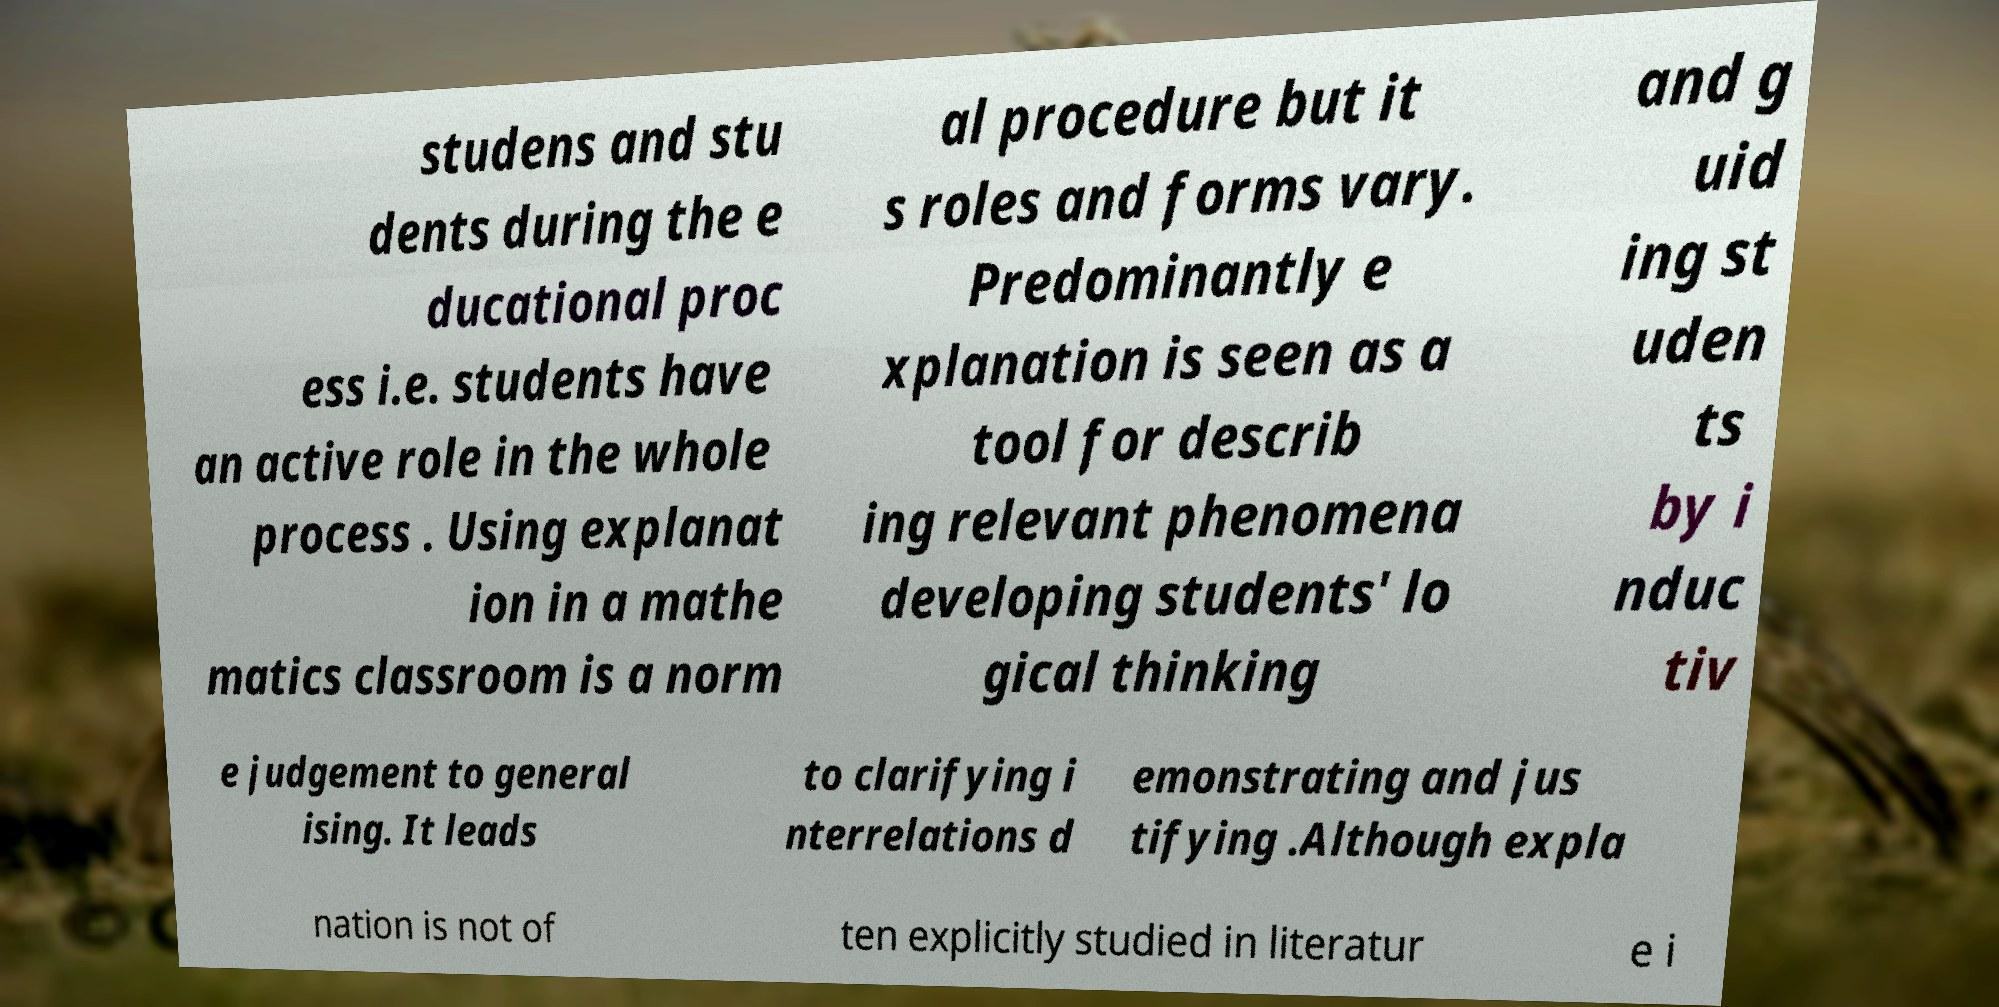I need the written content from this picture converted into text. Can you do that? studens and stu dents during the e ducational proc ess i.e. students have an active role in the whole process . Using explanat ion in a mathe matics classroom is a norm al procedure but it s roles and forms vary. Predominantly e xplanation is seen as a tool for describ ing relevant phenomena developing students' lo gical thinking and g uid ing st uden ts by i nduc tiv e judgement to general ising. It leads to clarifying i nterrelations d emonstrating and jus tifying .Although expla nation is not of ten explicitly studied in literatur e i 